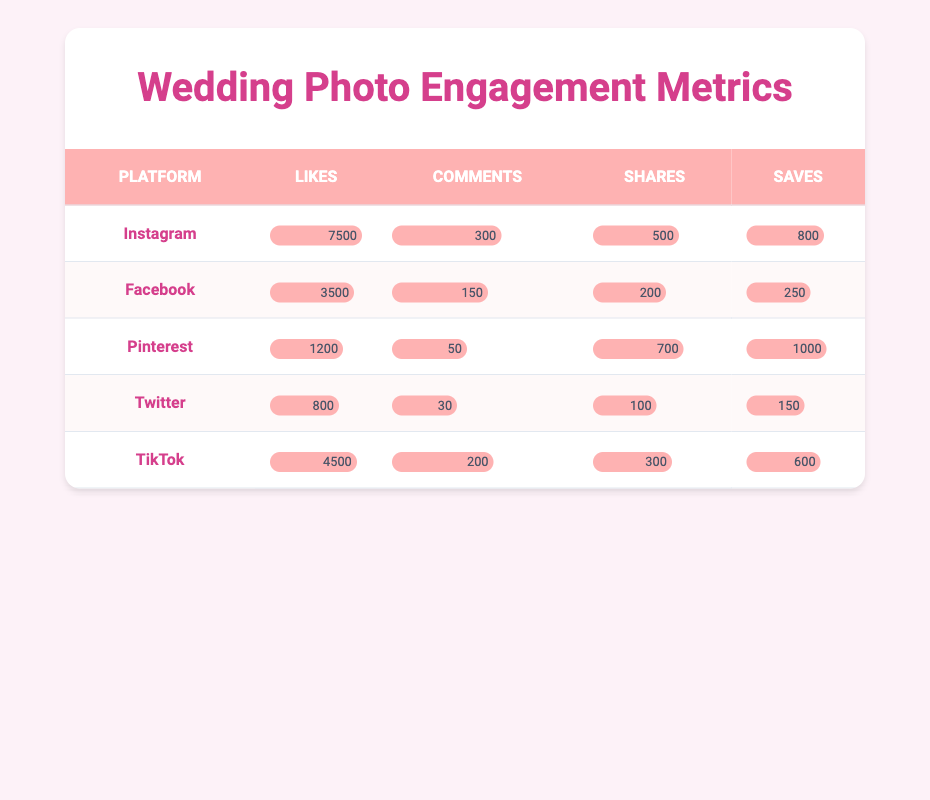What's the total number of likes across all platforms? To find the total number of likes, we add up the likes from each platform: Instagram (7500) + Facebook (3500) + Pinterest (1200) + Twitter (800) + TikTok (4500) = 17500.
Answer: 17500 Which platform has the highest number of comments? By comparing the comments count, Instagram has 300, Facebook has 150, Pinterest has 50, Twitter has 30, and TikTok has 200. The highest number is from Instagram with 300 comments.
Answer: Instagram What is the difference in shares between Instagram and Pinterest? Instagram has 500 shares, while Pinterest has 700 shares. To find the difference: 700 (Pinterest) - 500 (Instagram) = 200 shares.
Answer: 200 Is the number of saves on Facebook greater than the number of shares on Twitter? Facebook has 250 saves, and Twitter has 100 shares. Since 250 is greater than 100, the answer is yes.
Answer: Yes What platform has the lowest total engagement (likes + comments + shares + saves)? Calculate the total engagement for each platform: Instagram (7500 + 300 + 500 + 800 = 8500), Facebook (3500 + 150 + 200 + 250 = 4100), Pinterest (1200 + 50 + 700 + 1000 = 2950), Twitter (800 + 30 + 100 + 150 = 1080), TikTok (4500 + 200 + 300 + 600 = 5600). The lowest total is from Twitter with 1080.
Answer: Twitter What is the average number of shares across all platforms? To find the average, sum the shares: Instagram (500) + Facebook (200) + Pinterest (700) + Twitter (100) + TikTok (300) = 1800. Then, divide by the number of platforms (5): 1800 / 5 = 360.
Answer: 360 Did Pinterest receive more saves than Instagram? Pinterest has 1000 saves, and Instagram has 800 saves. Since 1000 is greater than 800, the answer is yes.
Answer: Yes Which platform shows the highest ratio of comments to likes? Calculate the ratio for each platform: Instagram (300/7500 = 0.04), Facebook (150/3500 = 0.042857), Pinterest (50/1200 = 0.04167), Twitter (30/800 = 0.0375), TikTok (200/4500 = 0.044444). The highest ratio is from TikTok (0.044444).
Answer: TikTok 